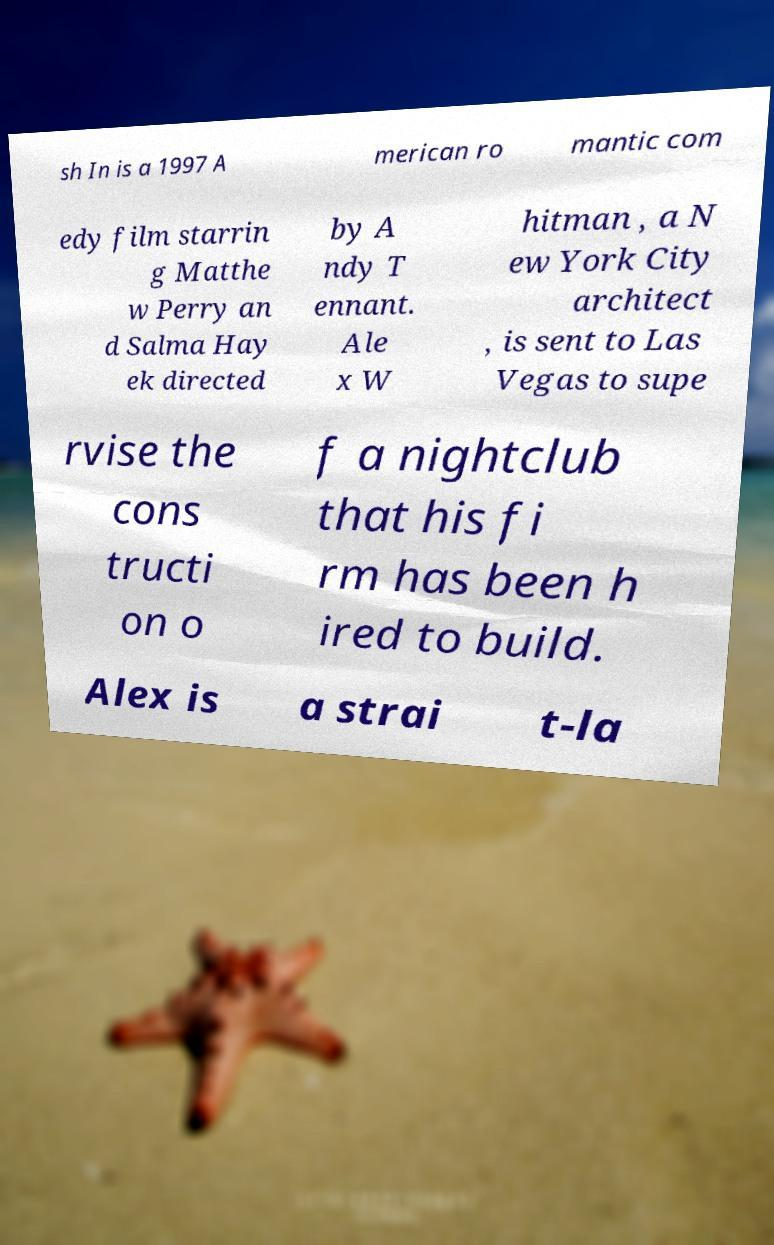For documentation purposes, I need the text within this image transcribed. Could you provide that? sh In is a 1997 A merican ro mantic com edy film starrin g Matthe w Perry an d Salma Hay ek directed by A ndy T ennant. Ale x W hitman , a N ew York City architect , is sent to Las Vegas to supe rvise the cons tructi on o f a nightclub that his fi rm has been h ired to build. Alex is a strai t-la 